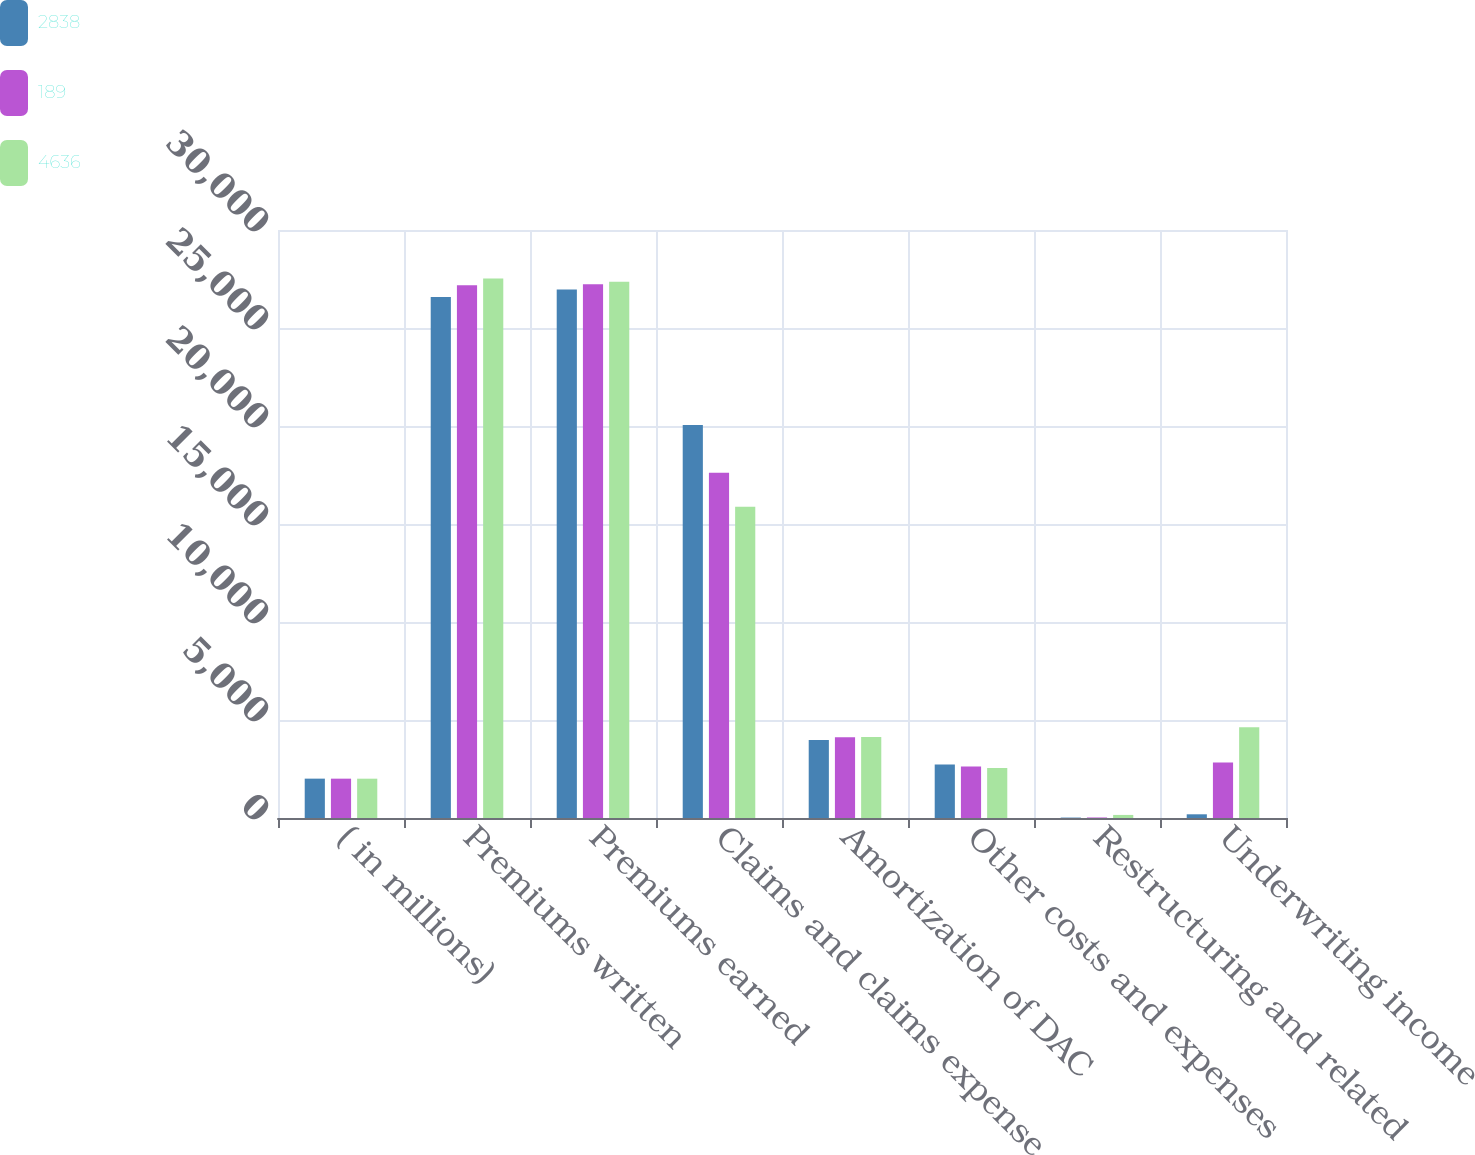Convert chart to OTSL. <chart><loc_0><loc_0><loc_500><loc_500><stacked_bar_chart><ecel><fcel>( in millions)<fcel>Premiums written<fcel>Premiums earned<fcel>Claims and claims expense<fcel>Amortization of DAC<fcel>Other costs and expenses<fcel>Restructuring and related<fcel>Underwriting income<nl><fcel>2838<fcel>2008<fcel>26584<fcel>26967<fcel>20046<fcel>3975<fcel>2735<fcel>22<fcel>189<nl><fcel>189<fcel>2007<fcel>27183<fcel>27232<fcel>17620<fcel>4121<fcel>2626<fcel>27<fcel>2838<nl><fcel>4636<fcel>2006<fcel>27525<fcel>27366<fcel>15885<fcel>4131<fcel>2557<fcel>157<fcel>4636<nl></chart> 